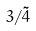<formula> <loc_0><loc_0><loc_500><loc_500>3 / \tilde { 4 }</formula> 